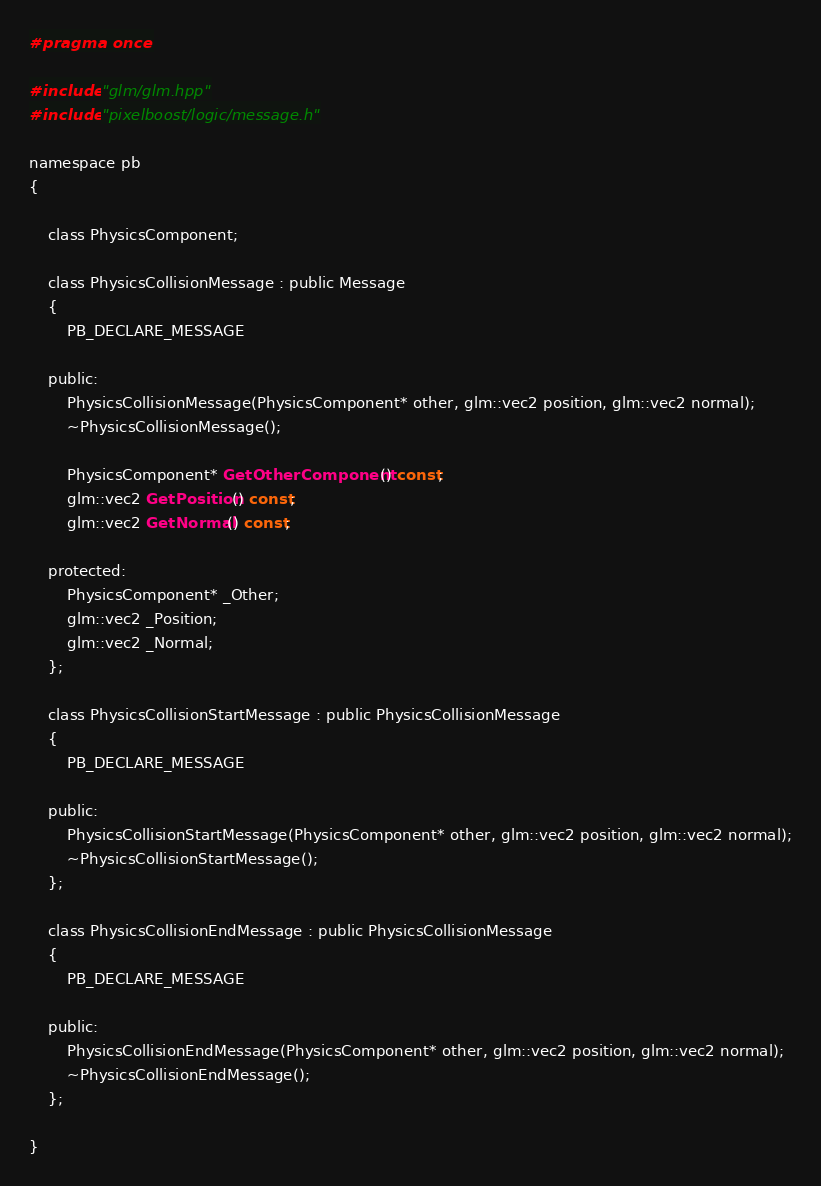Convert code to text. <code><loc_0><loc_0><loc_500><loc_500><_C_>#pragma once

#include "glm/glm.hpp"
#include "pixelboost/logic/message.h"

namespace pb
{

    class PhysicsComponent;
    
    class PhysicsCollisionMessage : public Message
    {
        PB_DECLARE_MESSAGE
        
    public:
        PhysicsCollisionMessage(PhysicsComponent* other, glm::vec2 position, glm::vec2 normal);
        ~PhysicsCollisionMessage();
        
        PhysicsComponent* GetOtherComponent() const;
        glm::vec2 GetPosition() const;
        glm::vec2 GetNormal() const;
        
    protected:
        PhysicsComponent* _Other;
        glm::vec2 _Position;
        glm::vec2 _Normal;
    };
    
    class PhysicsCollisionStartMessage : public PhysicsCollisionMessage
    {
        PB_DECLARE_MESSAGE
        
    public:
        PhysicsCollisionStartMessage(PhysicsComponent* other, glm::vec2 position, glm::vec2 normal);
        ~PhysicsCollisionStartMessage();
    };
    
    class PhysicsCollisionEndMessage : public PhysicsCollisionMessage
    {
        PB_DECLARE_MESSAGE
        
    public:
        PhysicsCollisionEndMessage(PhysicsComponent* other, glm::vec2 position, glm::vec2 normal);
        ~PhysicsCollisionEndMessage();
    };
    
}
</code> 